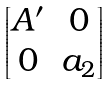<formula> <loc_0><loc_0><loc_500><loc_500>\begin{bmatrix} A ^ { \prime } & 0 \\ 0 & a _ { 2 } \end{bmatrix}</formula> 